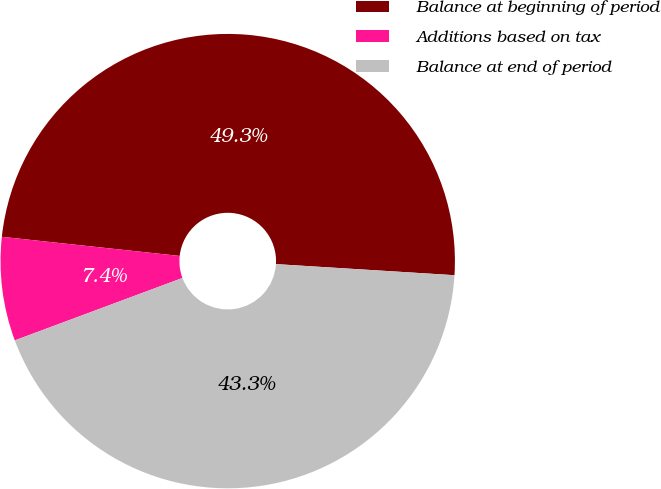Convert chart to OTSL. <chart><loc_0><loc_0><loc_500><loc_500><pie_chart><fcel>Balance at beginning of period<fcel>Additions based on tax<fcel>Balance at end of period<nl><fcel>49.28%<fcel>7.38%<fcel>43.34%<nl></chart> 